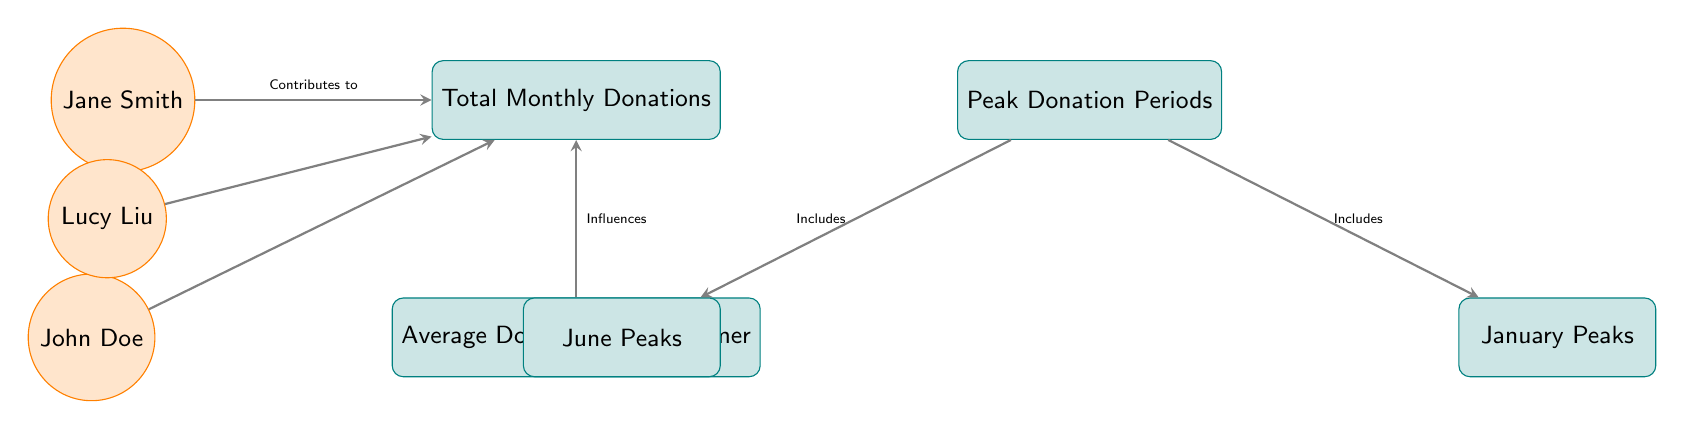What's the total monthly donations attributed to streamers? The diagram starts with the node "Total Monthly Donations", which is the main aggregate value reflecting all contributions from the streamers depicted. Since no specific numeric value is provided in the diagram, we cannot determine an exact number, but we know that it is influenced by the donations made by individual streamers.
Answer: Total Monthly Donations Who is one of the streamers contributing to total monthly donations? The diagram illustrates that multiple streamers contribute to total monthly donations. Specifically, Jane Smith is identified as one of the contributors through the arrow linking her to the "Total Monthly Donations" node.
Answer: Jane Smith What is a factor that influences the average donations per streamer? The arrows in the diagram indicate that the average donations per streamer are influenced by the total monthly donations. This relationship highlights that as total donations change, so too does the average amount per streamer.
Answer: Total Monthly Donations How many peak donation periods are shown in the diagram? Two boxes labeled "January Peaks" and "June Peaks" indicate the peak donation periods in the diagram. Therefore, we can count these to find that there are two distinct peak periods illustrated.
Answer: Two Which streamer is listed in the middle of the diagram? The diagram has a triangle formation with streamers around it. Lucy Liu is placed between Jane Smith and John Doe, representing her central position among the contributors.
Answer: Lucy Liu What do peak donation periods include? The diagram explicitly shows arrows linking the "Peak Donation Periods" node to two specific boxes labeled "January Peaks" and "June Peaks", denoting that these are the included peak periods.
Answer: January Peaks, June Peaks Which nodes are affected by the "Average Donations per Streamer"? According to the diagram, the "Average Donations per Streamer" directly influences the "Total Monthly Donations" node. Hence, we deduce that only the total monthly donations are affected by this average based on the flow direction shown.
Answer: Total Monthly Donations What does the arrow from streamers to total donations illustrate? The arrow connecting streamers such as Jane Smith, John Doe, and Lucy Liu to the "Total Monthly Donations" node indicates that these individuals contribute their donations to the total amount captured in that node.
Answer: Contributions What is the relationship between the "Peak Donation Periods" and the specific months shown? The relationships depicted through the arrows indicate that peak donation periods include specific months, specifically, January and June, as illustrated in their respective boxes. This shows a direct link between peak periods and the months mentioned.
Answer: Includes January Peaks, June Peaks 